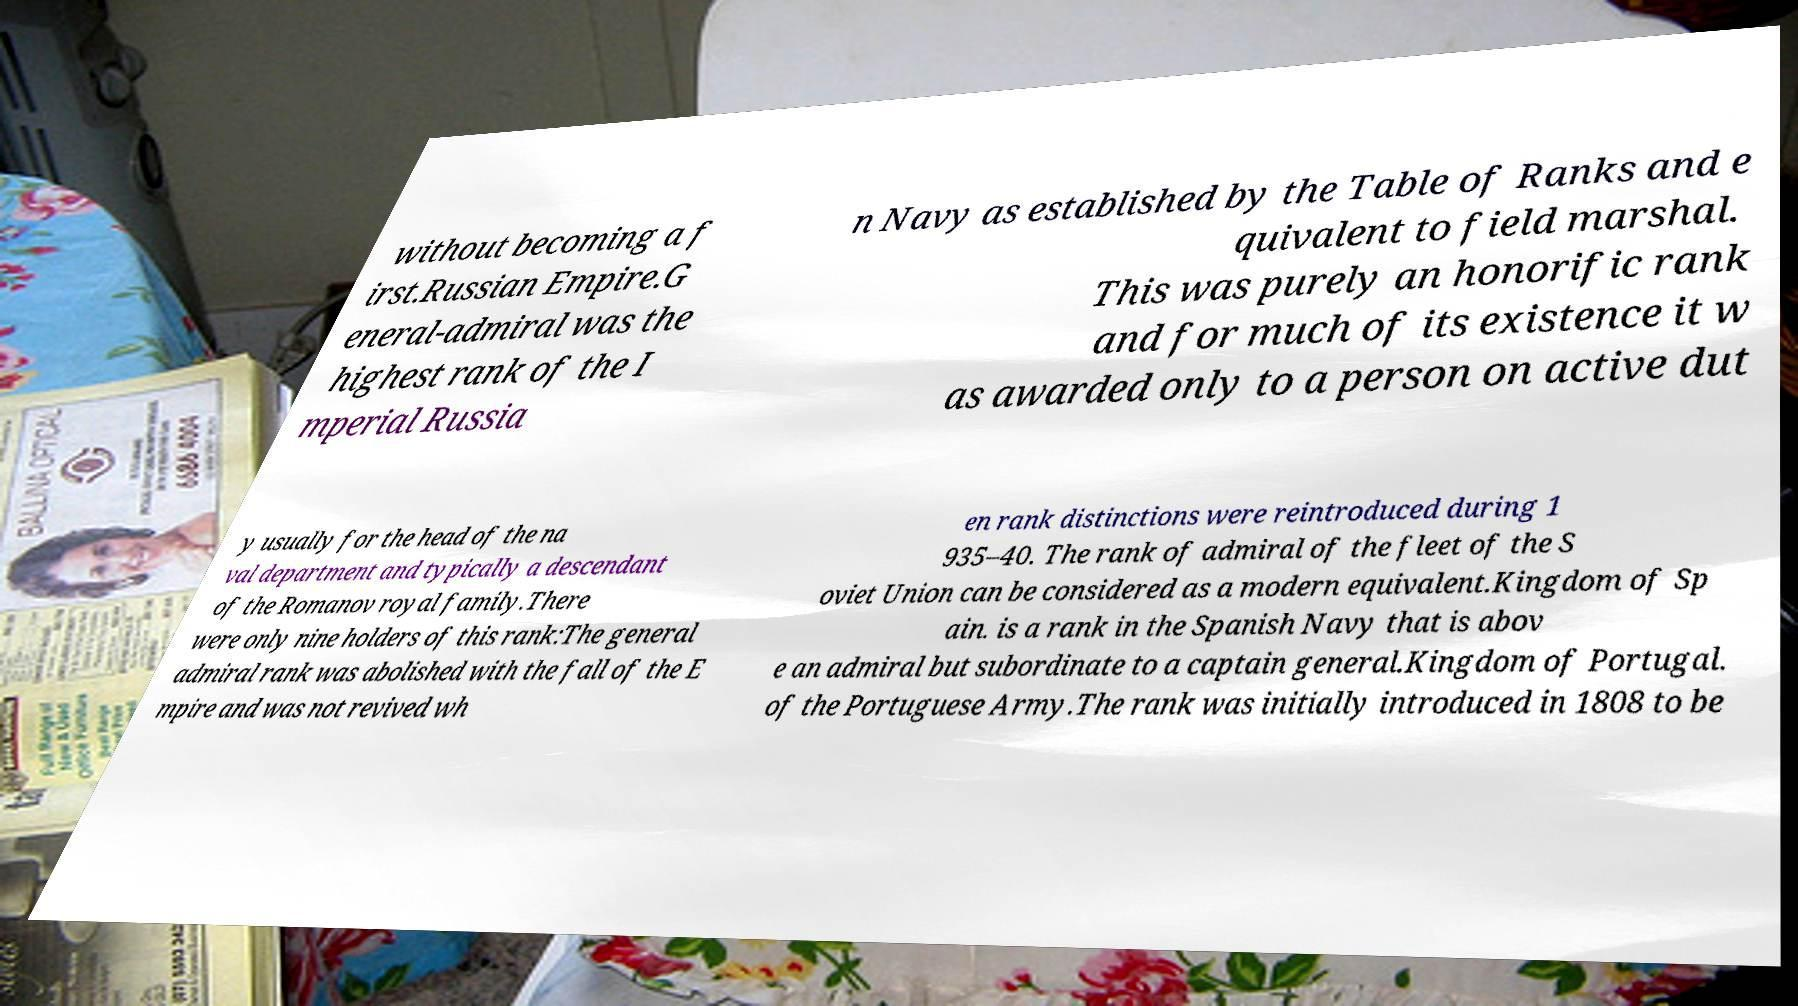I need the written content from this picture converted into text. Can you do that? without becoming a f irst.Russian Empire.G eneral-admiral was the highest rank of the I mperial Russia n Navy as established by the Table of Ranks and e quivalent to field marshal. This was purely an honorific rank and for much of its existence it w as awarded only to a person on active dut y usually for the head of the na val department and typically a descendant of the Romanov royal family.There were only nine holders of this rank:The general admiral rank was abolished with the fall of the E mpire and was not revived wh en rank distinctions were reintroduced during 1 935–40. The rank of admiral of the fleet of the S oviet Union can be considered as a modern equivalent.Kingdom of Sp ain. is a rank in the Spanish Navy that is abov e an admiral but subordinate to a captain general.Kingdom of Portugal. of the Portuguese Army.The rank was initially introduced in 1808 to be 